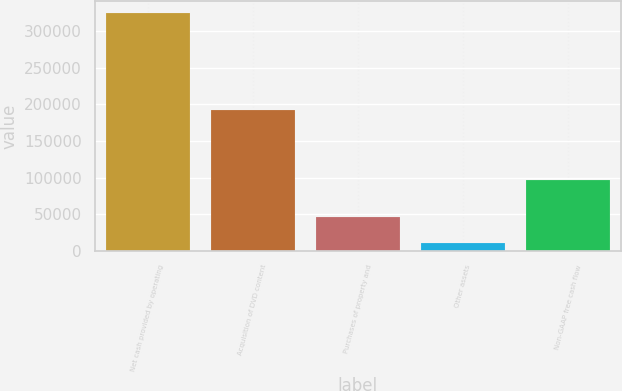Convert chart. <chart><loc_0><loc_0><loc_500><loc_500><bar_chart><fcel>Net cash provided by operating<fcel>Acquisition of DVD content<fcel>Purchases of property and<fcel>Other assets<fcel>Non-GAAP free cash flow<nl><fcel>325063<fcel>193044<fcel>45932<fcel>11035<fcel>97122<nl></chart> 